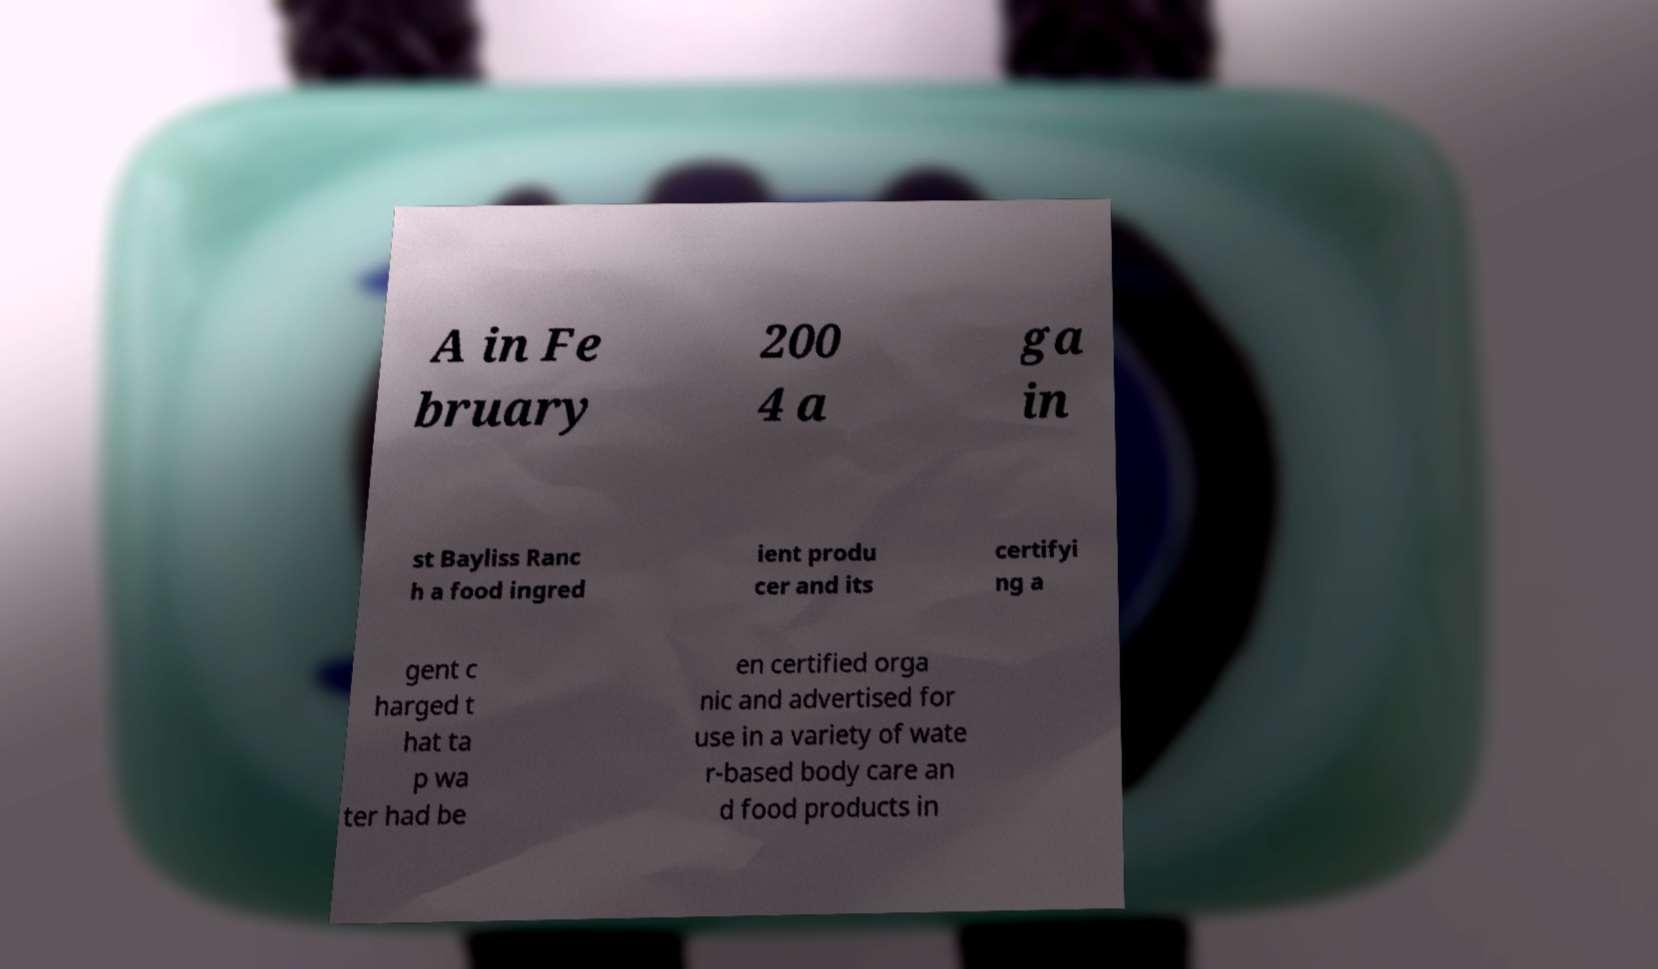I need the written content from this picture converted into text. Can you do that? A in Fe bruary 200 4 a ga in st Bayliss Ranc h a food ingred ient produ cer and its certifyi ng a gent c harged t hat ta p wa ter had be en certified orga nic and advertised for use in a variety of wate r-based body care an d food products in 